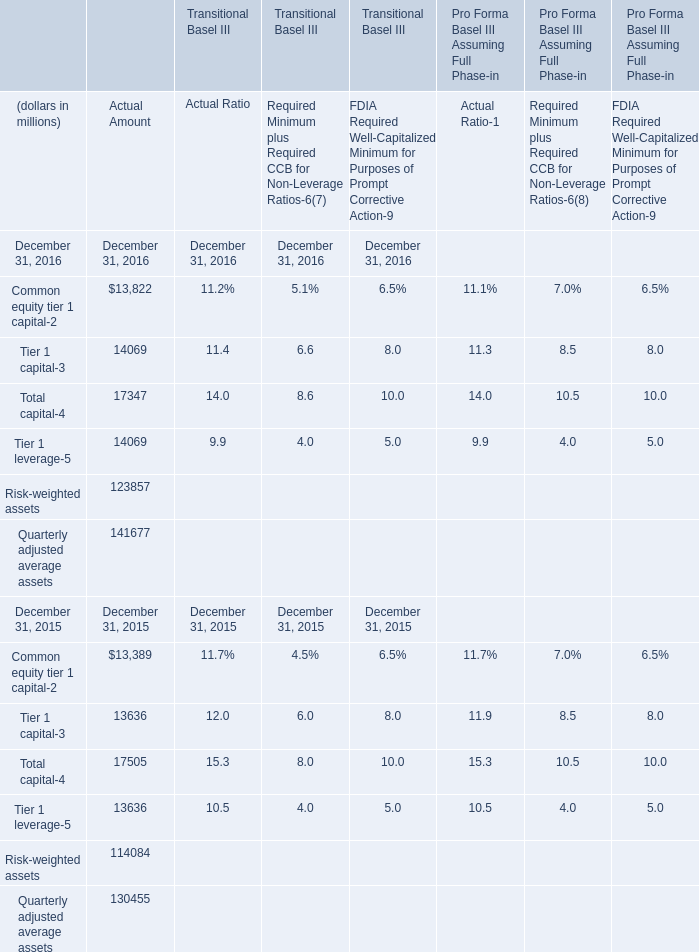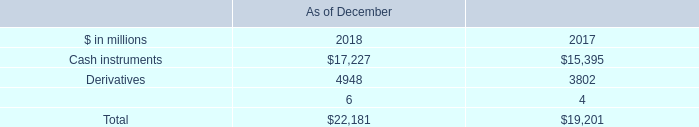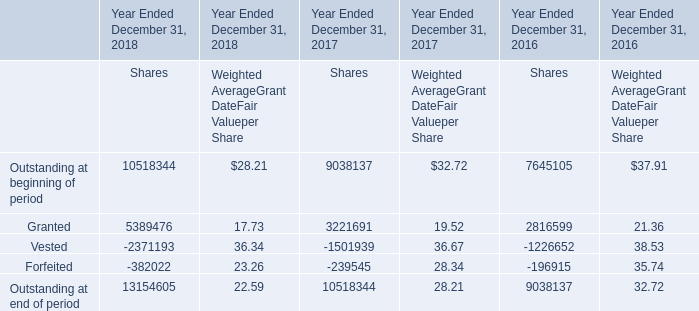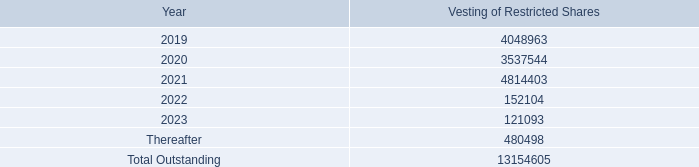Which year is Common equity tier 1 capital the highest? 
Answer: 2016. 